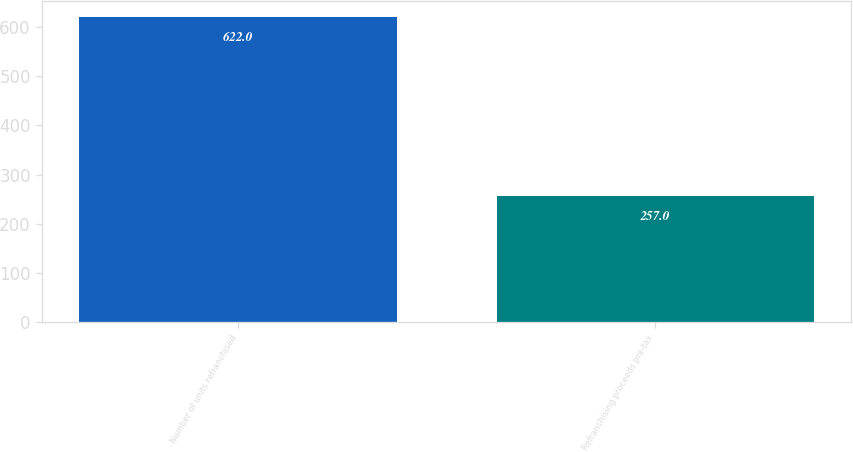Convert chart to OTSL. <chart><loc_0><loc_0><loc_500><loc_500><bar_chart><fcel>Number of units refranchised<fcel>Refranchising proceeds pre-tax<nl><fcel>622<fcel>257<nl></chart> 